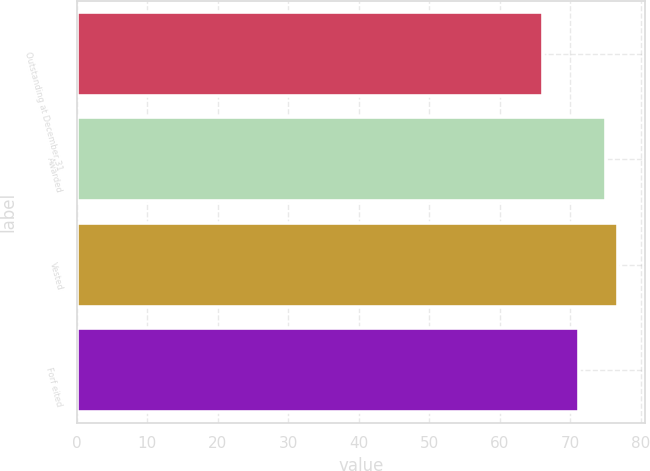<chart> <loc_0><loc_0><loc_500><loc_500><bar_chart><fcel>Outstanding at December 31<fcel>Awarded<fcel>Vested<fcel>Forf eited<nl><fcel>66.11<fcel>75.07<fcel>76.76<fcel>71.22<nl></chart> 